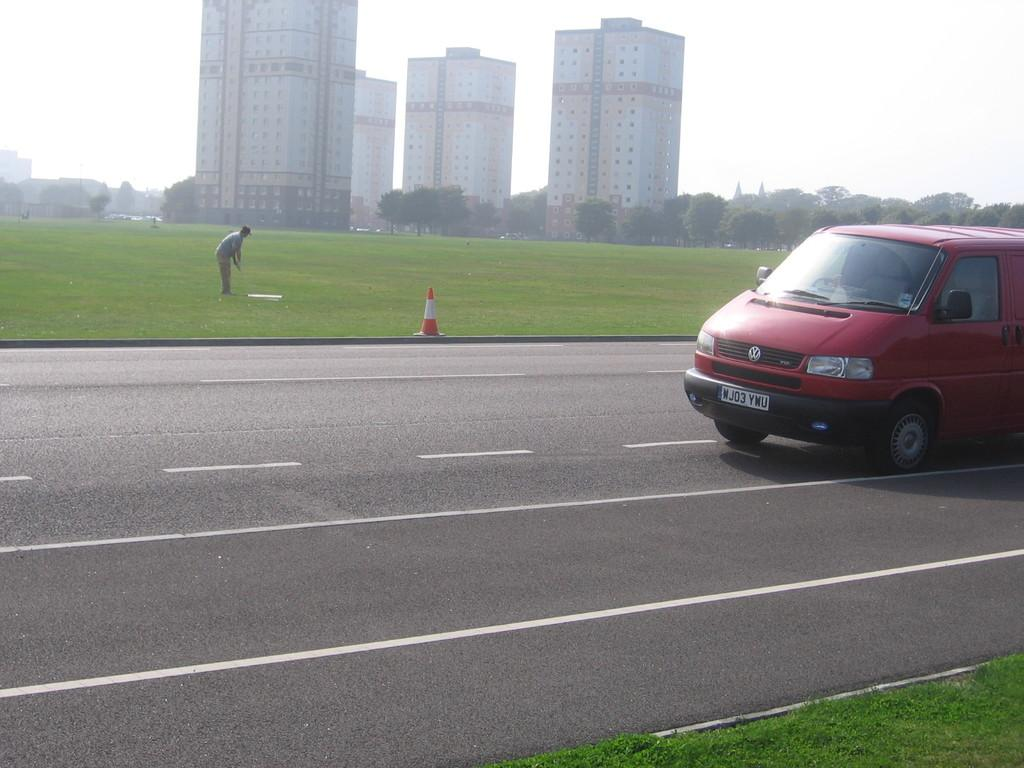What is the main subject of the image? There is a car on the road in the image. What is the person in the image doing? The person is standing on the grass in the image. What structures can be seen in the background of the image? There are buildings visible in the image. What type of vegetation is present in the image? There are trees present in the image. What type of basket is being used by the pet in the image? There is no pet or basket present in the image. 